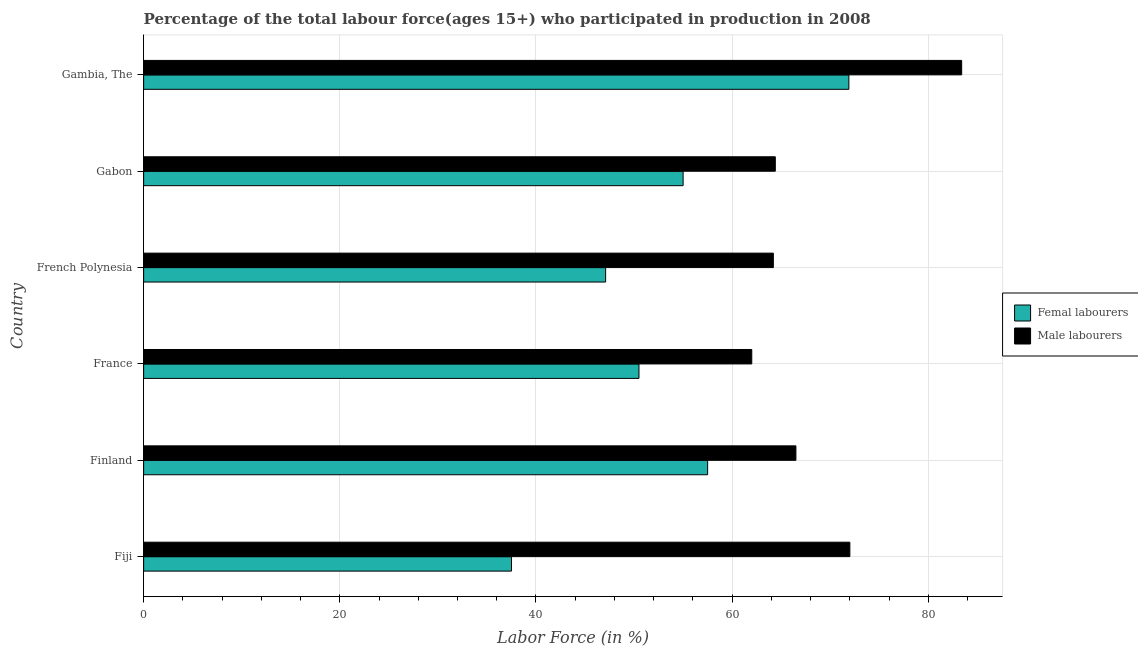How many groups of bars are there?
Your response must be concise. 6. Are the number of bars per tick equal to the number of legend labels?
Offer a terse response. Yes. Are the number of bars on each tick of the Y-axis equal?
Offer a very short reply. Yes. How many bars are there on the 1st tick from the top?
Provide a short and direct response. 2. How many bars are there on the 1st tick from the bottom?
Provide a short and direct response. 2. What is the label of the 5th group of bars from the top?
Ensure brevity in your answer.  Finland. What is the percentage of female labor force in Fiji?
Provide a short and direct response. 37.5. Across all countries, what is the maximum percentage of male labour force?
Keep it short and to the point. 83.4. Across all countries, what is the minimum percentage of female labor force?
Your answer should be compact. 37.5. In which country was the percentage of male labour force maximum?
Offer a very short reply. Gambia, The. In which country was the percentage of male labour force minimum?
Offer a terse response. France. What is the total percentage of male labour force in the graph?
Your response must be concise. 412.5. What is the difference between the percentage of male labour force in Gabon and that in Gambia, The?
Keep it short and to the point. -19. What is the difference between the percentage of female labor force in Gambia, The and the percentage of male labour force in French Polynesia?
Provide a short and direct response. 7.7. What is the average percentage of male labour force per country?
Offer a terse response. 68.75. What is the difference between the percentage of female labor force and percentage of male labour force in French Polynesia?
Keep it short and to the point. -17.1. What is the ratio of the percentage of female labor force in Fiji to that in French Polynesia?
Keep it short and to the point. 0.8. What is the difference between the highest and the lowest percentage of male labour force?
Give a very brief answer. 21.4. Is the sum of the percentage of female labor force in Finland and France greater than the maximum percentage of male labour force across all countries?
Offer a terse response. Yes. What does the 2nd bar from the top in France represents?
Your answer should be very brief. Femal labourers. What does the 1st bar from the bottom in Fiji represents?
Provide a short and direct response. Femal labourers. Does the graph contain grids?
Your response must be concise. Yes. Where does the legend appear in the graph?
Your response must be concise. Center right. How many legend labels are there?
Make the answer very short. 2. How are the legend labels stacked?
Your answer should be very brief. Vertical. What is the title of the graph?
Offer a terse response. Percentage of the total labour force(ages 15+) who participated in production in 2008. What is the label or title of the Y-axis?
Offer a very short reply. Country. What is the Labor Force (in %) in Femal labourers in Fiji?
Ensure brevity in your answer.  37.5. What is the Labor Force (in %) of Male labourers in Fiji?
Offer a terse response. 72. What is the Labor Force (in %) of Femal labourers in Finland?
Offer a very short reply. 57.5. What is the Labor Force (in %) in Male labourers in Finland?
Ensure brevity in your answer.  66.5. What is the Labor Force (in %) of Femal labourers in France?
Ensure brevity in your answer.  50.5. What is the Labor Force (in %) in Femal labourers in French Polynesia?
Your answer should be very brief. 47.1. What is the Labor Force (in %) in Male labourers in French Polynesia?
Offer a terse response. 64.2. What is the Labor Force (in %) in Male labourers in Gabon?
Keep it short and to the point. 64.4. What is the Labor Force (in %) in Femal labourers in Gambia, The?
Offer a very short reply. 71.9. What is the Labor Force (in %) of Male labourers in Gambia, The?
Give a very brief answer. 83.4. Across all countries, what is the maximum Labor Force (in %) in Femal labourers?
Ensure brevity in your answer.  71.9. Across all countries, what is the maximum Labor Force (in %) in Male labourers?
Make the answer very short. 83.4. Across all countries, what is the minimum Labor Force (in %) in Femal labourers?
Make the answer very short. 37.5. What is the total Labor Force (in %) in Femal labourers in the graph?
Your answer should be compact. 319.5. What is the total Labor Force (in %) of Male labourers in the graph?
Make the answer very short. 412.5. What is the difference between the Labor Force (in %) of Male labourers in Fiji and that in Finland?
Provide a succinct answer. 5.5. What is the difference between the Labor Force (in %) of Male labourers in Fiji and that in France?
Provide a succinct answer. 10. What is the difference between the Labor Force (in %) of Femal labourers in Fiji and that in Gabon?
Make the answer very short. -17.5. What is the difference between the Labor Force (in %) in Male labourers in Fiji and that in Gabon?
Keep it short and to the point. 7.6. What is the difference between the Labor Force (in %) of Femal labourers in Fiji and that in Gambia, The?
Give a very brief answer. -34.4. What is the difference between the Labor Force (in %) of Male labourers in Fiji and that in Gambia, The?
Ensure brevity in your answer.  -11.4. What is the difference between the Labor Force (in %) of Femal labourers in Finland and that in French Polynesia?
Offer a terse response. 10.4. What is the difference between the Labor Force (in %) in Male labourers in Finland and that in French Polynesia?
Offer a very short reply. 2.3. What is the difference between the Labor Force (in %) in Femal labourers in Finland and that in Gabon?
Your answer should be compact. 2.5. What is the difference between the Labor Force (in %) of Femal labourers in Finland and that in Gambia, The?
Provide a short and direct response. -14.4. What is the difference between the Labor Force (in %) of Male labourers in Finland and that in Gambia, The?
Your answer should be compact. -16.9. What is the difference between the Labor Force (in %) of Male labourers in France and that in Gabon?
Offer a very short reply. -2.4. What is the difference between the Labor Force (in %) of Femal labourers in France and that in Gambia, The?
Offer a terse response. -21.4. What is the difference between the Labor Force (in %) of Male labourers in France and that in Gambia, The?
Give a very brief answer. -21.4. What is the difference between the Labor Force (in %) in Femal labourers in French Polynesia and that in Gambia, The?
Ensure brevity in your answer.  -24.8. What is the difference between the Labor Force (in %) in Male labourers in French Polynesia and that in Gambia, The?
Provide a short and direct response. -19.2. What is the difference between the Labor Force (in %) of Femal labourers in Gabon and that in Gambia, The?
Provide a short and direct response. -16.9. What is the difference between the Labor Force (in %) of Male labourers in Gabon and that in Gambia, The?
Offer a very short reply. -19. What is the difference between the Labor Force (in %) in Femal labourers in Fiji and the Labor Force (in %) in Male labourers in Finland?
Provide a short and direct response. -29. What is the difference between the Labor Force (in %) of Femal labourers in Fiji and the Labor Force (in %) of Male labourers in France?
Give a very brief answer. -24.5. What is the difference between the Labor Force (in %) in Femal labourers in Fiji and the Labor Force (in %) in Male labourers in French Polynesia?
Your response must be concise. -26.7. What is the difference between the Labor Force (in %) in Femal labourers in Fiji and the Labor Force (in %) in Male labourers in Gabon?
Offer a very short reply. -26.9. What is the difference between the Labor Force (in %) of Femal labourers in Fiji and the Labor Force (in %) of Male labourers in Gambia, The?
Ensure brevity in your answer.  -45.9. What is the difference between the Labor Force (in %) in Femal labourers in Finland and the Labor Force (in %) in Male labourers in France?
Make the answer very short. -4.5. What is the difference between the Labor Force (in %) in Femal labourers in Finland and the Labor Force (in %) in Male labourers in French Polynesia?
Your response must be concise. -6.7. What is the difference between the Labor Force (in %) in Femal labourers in Finland and the Labor Force (in %) in Male labourers in Gambia, The?
Your answer should be very brief. -25.9. What is the difference between the Labor Force (in %) of Femal labourers in France and the Labor Force (in %) of Male labourers in French Polynesia?
Your answer should be very brief. -13.7. What is the difference between the Labor Force (in %) of Femal labourers in France and the Labor Force (in %) of Male labourers in Gabon?
Provide a short and direct response. -13.9. What is the difference between the Labor Force (in %) in Femal labourers in France and the Labor Force (in %) in Male labourers in Gambia, The?
Offer a very short reply. -32.9. What is the difference between the Labor Force (in %) in Femal labourers in French Polynesia and the Labor Force (in %) in Male labourers in Gabon?
Provide a short and direct response. -17.3. What is the difference between the Labor Force (in %) in Femal labourers in French Polynesia and the Labor Force (in %) in Male labourers in Gambia, The?
Ensure brevity in your answer.  -36.3. What is the difference between the Labor Force (in %) in Femal labourers in Gabon and the Labor Force (in %) in Male labourers in Gambia, The?
Offer a terse response. -28.4. What is the average Labor Force (in %) of Femal labourers per country?
Give a very brief answer. 53.25. What is the average Labor Force (in %) in Male labourers per country?
Offer a terse response. 68.75. What is the difference between the Labor Force (in %) of Femal labourers and Labor Force (in %) of Male labourers in Fiji?
Keep it short and to the point. -34.5. What is the difference between the Labor Force (in %) of Femal labourers and Labor Force (in %) of Male labourers in French Polynesia?
Ensure brevity in your answer.  -17.1. What is the difference between the Labor Force (in %) in Femal labourers and Labor Force (in %) in Male labourers in Gambia, The?
Offer a very short reply. -11.5. What is the ratio of the Labor Force (in %) in Femal labourers in Fiji to that in Finland?
Offer a terse response. 0.65. What is the ratio of the Labor Force (in %) of Male labourers in Fiji to that in Finland?
Keep it short and to the point. 1.08. What is the ratio of the Labor Force (in %) in Femal labourers in Fiji to that in France?
Ensure brevity in your answer.  0.74. What is the ratio of the Labor Force (in %) of Male labourers in Fiji to that in France?
Keep it short and to the point. 1.16. What is the ratio of the Labor Force (in %) in Femal labourers in Fiji to that in French Polynesia?
Make the answer very short. 0.8. What is the ratio of the Labor Force (in %) in Male labourers in Fiji to that in French Polynesia?
Your response must be concise. 1.12. What is the ratio of the Labor Force (in %) of Femal labourers in Fiji to that in Gabon?
Offer a terse response. 0.68. What is the ratio of the Labor Force (in %) of Male labourers in Fiji to that in Gabon?
Offer a terse response. 1.12. What is the ratio of the Labor Force (in %) in Femal labourers in Fiji to that in Gambia, The?
Make the answer very short. 0.52. What is the ratio of the Labor Force (in %) in Male labourers in Fiji to that in Gambia, The?
Provide a short and direct response. 0.86. What is the ratio of the Labor Force (in %) in Femal labourers in Finland to that in France?
Your answer should be very brief. 1.14. What is the ratio of the Labor Force (in %) in Male labourers in Finland to that in France?
Keep it short and to the point. 1.07. What is the ratio of the Labor Force (in %) in Femal labourers in Finland to that in French Polynesia?
Keep it short and to the point. 1.22. What is the ratio of the Labor Force (in %) in Male labourers in Finland to that in French Polynesia?
Offer a very short reply. 1.04. What is the ratio of the Labor Force (in %) of Femal labourers in Finland to that in Gabon?
Ensure brevity in your answer.  1.05. What is the ratio of the Labor Force (in %) of Male labourers in Finland to that in Gabon?
Your response must be concise. 1.03. What is the ratio of the Labor Force (in %) in Femal labourers in Finland to that in Gambia, The?
Ensure brevity in your answer.  0.8. What is the ratio of the Labor Force (in %) of Male labourers in Finland to that in Gambia, The?
Offer a very short reply. 0.8. What is the ratio of the Labor Force (in %) in Femal labourers in France to that in French Polynesia?
Provide a succinct answer. 1.07. What is the ratio of the Labor Force (in %) in Male labourers in France to that in French Polynesia?
Give a very brief answer. 0.97. What is the ratio of the Labor Force (in %) in Femal labourers in France to that in Gabon?
Your response must be concise. 0.92. What is the ratio of the Labor Force (in %) of Male labourers in France to that in Gabon?
Ensure brevity in your answer.  0.96. What is the ratio of the Labor Force (in %) in Femal labourers in France to that in Gambia, The?
Give a very brief answer. 0.7. What is the ratio of the Labor Force (in %) in Male labourers in France to that in Gambia, The?
Your response must be concise. 0.74. What is the ratio of the Labor Force (in %) in Femal labourers in French Polynesia to that in Gabon?
Provide a succinct answer. 0.86. What is the ratio of the Labor Force (in %) in Male labourers in French Polynesia to that in Gabon?
Provide a succinct answer. 1. What is the ratio of the Labor Force (in %) of Femal labourers in French Polynesia to that in Gambia, The?
Offer a terse response. 0.66. What is the ratio of the Labor Force (in %) of Male labourers in French Polynesia to that in Gambia, The?
Offer a terse response. 0.77. What is the ratio of the Labor Force (in %) in Femal labourers in Gabon to that in Gambia, The?
Your response must be concise. 0.77. What is the ratio of the Labor Force (in %) of Male labourers in Gabon to that in Gambia, The?
Give a very brief answer. 0.77. What is the difference between the highest and the second highest Labor Force (in %) in Femal labourers?
Make the answer very short. 14.4. What is the difference between the highest and the second highest Labor Force (in %) in Male labourers?
Give a very brief answer. 11.4. What is the difference between the highest and the lowest Labor Force (in %) of Femal labourers?
Offer a very short reply. 34.4. What is the difference between the highest and the lowest Labor Force (in %) in Male labourers?
Your answer should be compact. 21.4. 